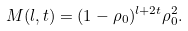<formula> <loc_0><loc_0><loc_500><loc_500>M ( l , t ) = ( 1 - \rho _ { 0 } ) ^ { l + 2 t } \rho _ { 0 } ^ { 2 } .</formula> 